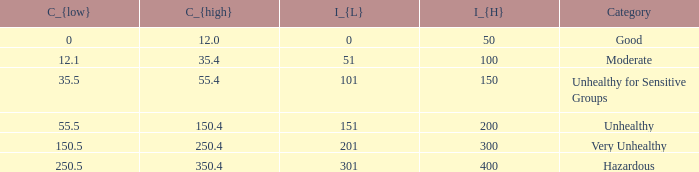What's the C_{high} when the C_{low} value is 250.5? 350.4. 